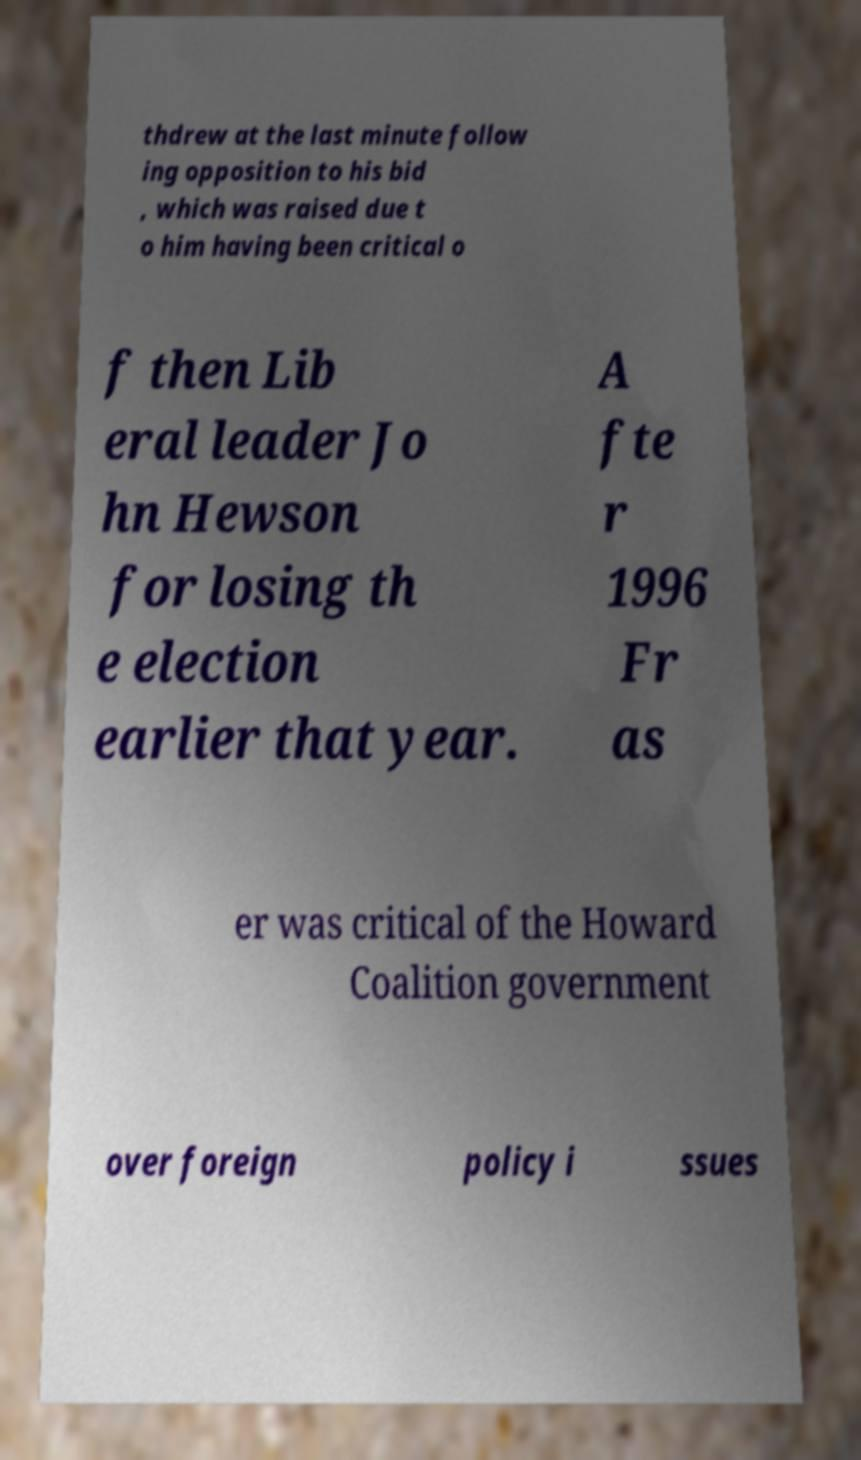Can you accurately transcribe the text from the provided image for me? thdrew at the last minute follow ing opposition to his bid , which was raised due t o him having been critical o f then Lib eral leader Jo hn Hewson for losing th e election earlier that year. A fte r 1996 Fr as er was critical of the Howard Coalition government over foreign policy i ssues 